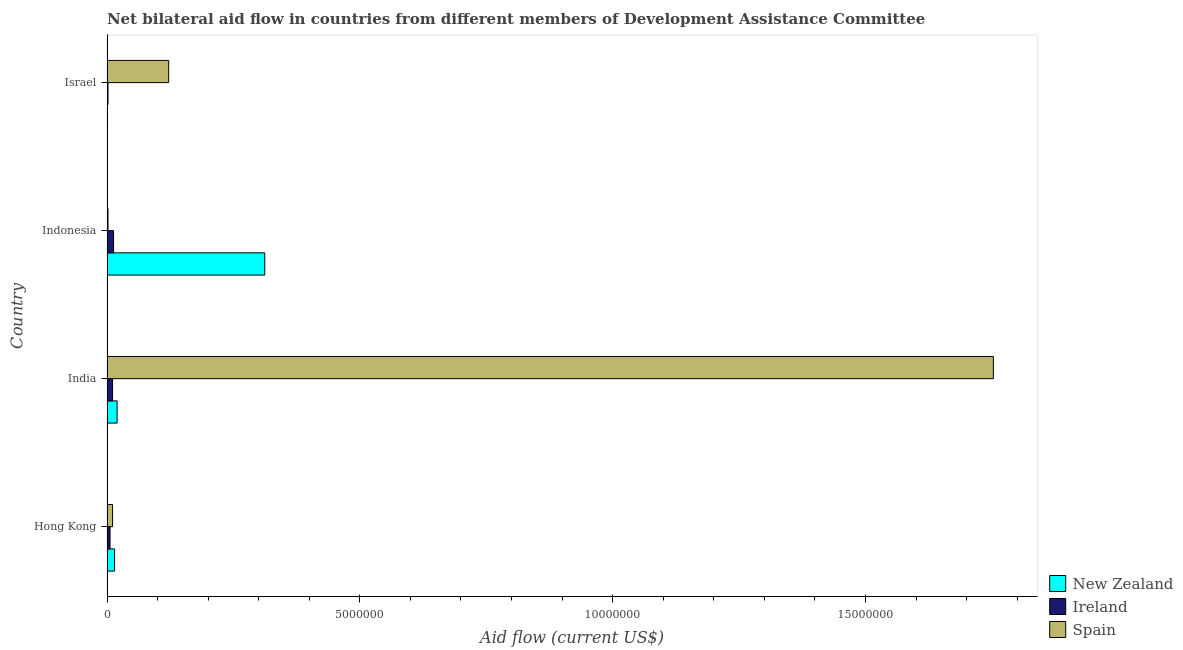How many groups of bars are there?
Your answer should be compact. 4. Are the number of bars on each tick of the Y-axis equal?
Your answer should be compact. Yes. In how many cases, is the number of bars for a given country not equal to the number of legend labels?
Provide a succinct answer. 0. What is the amount of aid provided by ireland in Hong Kong?
Provide a short and direct response. 6.00e+04. Across all countries, what is the maximum amount of aid provided by new zealand?
Ensure brevity in your answer.  3.12e+06. Across all countries, what is the minimum amount of aid provided by new zealand?
Offer a very short reply. 10000. In which country was the amount of aid provided by ireland maximum?
Your answer should be very brief. Indonesia. What is the total amount of aid provided by new zealand in the graph?
Provide a succinct answer. 3.48e+06. What is the difference between the amount of aid provided by spain in Hong Kong and that in India?
Ensure brevity in your answer.  -1.74e+07. What is the difference between the amount of aid provided by spain in Israel and the amount of aid provided by new zealand in Indonesia?
Give a very brief answer. -1.90e+06. What is the average amount of aid provided by ireland per country?
Provide a short and direct response. 8.00e+04. What is the difference between the amount of aid provided by ireland and amount of aid provided by spain in Israel?
Your answer should be compact. -1.20e+06. In how many countries, is the amount of aid provided by spain greater than 9000000 US$?
Keep it short and to the point. 1. What is the ratio of the amount of aid provided by new zealand in Indonesia to that in Israel?
Ensure brevity in your answer.  312. Is the amount of aid provided by new zealand in Hong Kong less than that in Israel?
Make the answer very short. No. What is the difference between the highest and the lowest amount of aid provided by spain?
Make the answer very short. 1.75e+07. In how many countries, is the amount of aid provided by spain greater than the average amount of aid provided by spain taken over all countries?
Your answer should be compact. 1. Is the sum of the amount of aid provided by ireland in Indonesia and Israel greater than the maximum amount of aid provided by spain across all countries?
Offer a very short reply. No. What does the 1st bar from the top in India represents?
Offer a terse response. Spain. What does the 1st bar from the bottom in Israel represents?
Offer a very short reply. New Zealand. Is it the case that in every country, the sum of the amount of aid provided by new zealand and amount of aid provided by ireland is greater than the amount of aid provided by spain?
Offer a terse response. No. Are all the bars in the graph horizontal?
Provide a succinct answer. Yes. How many countries are there in the graph?
Make the answer very short. 4. Are the values on the major ticks of X-axis written in scientific E-notation?
Make the answer very short. No. Does the graph contain any zero values?
Keep it short and to the point. No. Where does the legend appear in the graph?
Offer a very short reply. Bottom right. How many legend labels are there?
Provide a succinct answer. 3. How are the legend labels stacked?
Your answer should be very brief. Vertical. What is the title of the graph?
Provide a short and direct response. Net bilateral aid flow in countries from different members of Development Assistance Committee. What is the label or title of the X-axis?
Your answer should be very brief. Aid flow (current US$). What is the Aid flow (current US$) in Ireland in Hong Kong?
Offer a terse response. 6.00e+04. What is the Aid flow (current US$) in Spain in Hong Kong?
Ensure brevity in your answer.  1.10e+05. What is the Aid flow (current US$) in Ireland in India?
Ensure brevity in your answer.  1.10e+05. What is the Aid flow (current US$) of Spain in India?
Keep it short and to the point. 1.75e+07. What is the Aid flow (current US$) in New Zealand in Indonesia?
Offer a terse response. 3.12e+06. What is the Aid flow (current US$) of Ireland in Indonesia?
Provide a short and direct response. 1.30e+05. What is the Aid flow (current US$) of Spain in Indonesia?
Offer a very short reply. 2.00e+04. What is the Aid flow (current US$) of New Zealand in Israel?
Make the answer very short. 10000. What is the Aid flow (current US$) of Spain in Israel?
Provide a short and direct response. 1.22e+06. Across all countries, what is the maximum Aid flow (current US$) in New Zealand?
Your answer should be very brief. 3.12e+06. Across all countries, what is the maximum Aid flow (current US$) of Ireland?
Your answer should be very brief. 1.30e+05. Across all countries, what is the maximum Aid flow (current US$) in Spain?
Keep it short and to the point. 1.75e+07. Across all countries, what is the minimum Aid flow (current US$) of New Zealand?
Offer a very short reply. 10000. Across all countries, what is the minimum Aid flow (current US$) of Ireland?
Offer a very short reply. 2.00e+04. Across all countries, what is the minimum Aid flow (current US$) in Spain?
Your answer should be compact. 2.00e+04. What is the total Aid flow (current US$) of New Zealand in the graph?
Your answer should be very brief. 3.48e+06. What is the total Aid flow (current US$) of Ireland in the graph?
Give a very brief answer. 3.20e+05. What is the total Aid flow (current US$) of Spain in the graph?
Provide a short and direct response. 1.89e+07. What is the difference between the Aid flow (current US$) in Spain in Hong Kong and that in India?
Provide a succinct answer. -1.74e+07. What is the difference between the Aid flow (current US$) in New Zealand in Hong Kong and that in Indonesia?
Make the answer very short. -2.97e+06. What is the difference between the Aid flow (current US$) in Spain in Hong Kong and that in Indonesia?
Give a very brief answer. 9.00e+04. What is the difference between the Aid flow (current US$) in New Zealand in Hong Kong and that in Israel?
Ensure brevity in your answer.  1.40e+05. What is the difference between the Aid flow (current US$) of Spain in Hong Kong and that in Israel?
Your answer should be very brief. -1.11e+06. What is the difference between the Aid flow (current US$) in New Zealand in India and that in Indonesia?
Give a very brief answer. -2.92e+06. What is the difference between the Aid flow (current US$) in Spain in India and that in Indonesia?
Provide a short and direct response. 1.75e+07. What is the difference between the Aid flow (current US$) in Spain in India and that in Israel?
Ensure brevity in your answer.  1.63e+07. What is the difference between the Aid flow (current US$) of New Zealand in Indonesia and that in Israel?
Offer a terse response. 3.11e+06. What is the difference between the Aid flow (current US$) in Spain in Indonesia and that in Israel?
Ensure brevity in your answer.  -1.20e+06. What is the difference between the Aid flow (current US$) of New Zealand in Hong Kong and the Aid flow (current US$) of Spain in India?
Your answer should be compact. -1.74e+07. What is the difference between the Aid flow (current US$) of Ireland in Hong Kong and the Aid flow (current US$) of Spain in India?
Your answer should be compact. -1.75e+07. What is the difference between the Aid flow (current US$) in New Zealand in Hong Kong and the Aid flow (current US$) in Ireland in Indonesia?
Provide a short and direct response. 2.00e+04. What is the difference between the Aid flow (current US$) of Ireland in Hong Kong and the Aid flow (current US$) of Spain in Indonesia?
Provide a short and direct response. 4.00e+04. What is the difference between the Aid flow (current US$) in New Zealand in Hong Kong and the Aid flow (current US$) in Ireland in Israel?
Offer a very short reply. 1.30e+05. What is the difference between the Aid flow (current US$) of New Zealand in Hong Kong and the Aid flow (current US$) of Spain in Israel?
Your response must be concise. -1.07e+06. What is the difference between the Aid flow (current US$) in Ireland in Hong Kong and the Aid flow (current US$) in Spain in Israel?
Offer a very short reply. -1.16e+06. What is the difference between the Aid flow (current US$) in Ireland in India and the Aid flow (current US$) in Spain in Indonesia?
Make the answer very short. 9.00e+04. What is the difference between the Aid flow (current US$) of New Zealand in India and the Aid flow (current US$) of Ireland in Israel?
Your response must be concise. 1.80e+05. What is the difference between the Aid flow (current US$) in New Zealand in India and the Aid flow (current US$) in Spain in Israel?
Offer a very short reply. -1.02e+06. What is the difference between the Aid flow (current US$) of Ireland in India and the Aid flow (current US$) of Spain in Israel?
Provide a succinct answer. -1.11e+06. What is the difference between the Aid flow (current US$) in New Zealand in Indonesia and the Aid flow (current US$) in Ireland in Israel?
Your answer should be compact. 3.10e+06. What is the difference between the Aid flow (current US$) in New Zealand in Indonesia and the Aid flow (current US$) in Spain in Israel?
Your answer should be compact. 1.90e+06. What is the difference between the Aid flow (current US$) in Ireland in Indonesia and the Aid flow (current US$) in Spain in Israel?
Ensure brevity in your answer.  -1.09e+06. What is the average Aid flow (current US$) of New Zealand per country?
Your response must be concise. 8.70e+05. What is the average Aid flow (current US$) of Spain per country?
Your answer should be compact. 4.72e+06. What is the difference between the Aid flow (current US$) in New Zealand and Aid flow (current US$) in Ireland in Hong Kong?
Your response must be concise. 9.00e+04. What is the difference between the Aid flow (current US$) of Ireland and Aid flow (current US$) of Spain in Hong Kong?
Provide a succinct answer. -5.00e+04. What is the difference between the Aid flow (current US$) in New Zealand and Aid flow (current US$) in Spain in India?
Make the answer very short. -1.73e+07. What is the difference between the Aid flow (current US$) of Ireland and Aid flow (current US$) of Spain in India?
Your response must be concise. -1.74e+07. What is the difference between the Aid flow (current US$) in New Zealand and Aid flow (current US$) in Ireland in Indonesia?
Your answer should be very brief. 2.99e+06. What is the difference between the Aid flow (current US$) in New Zealand and Aid flow (current US$) in Spain in Indonesia?
Provide a short and direct response. 3.10e+06. What is the difference between the Aid flow (current US$) of Ireland and Aid flow (current US$) of Spain in Indonesia?
Your answer should be very brief. 1.10e+05. What is the difference between the Aid flow (current US$) in New Zealand and Aid flow (current US$) in Ireland in Israel?
Make the answer very short. -10000. What is the difference between the Aid flow (current US$) in New Zealand and Aid flow (current US$) in Spain in Israel?
Offer a terse response. -1.21e+06. What is the difference between the Aid flow (current US$) of Ireland and Aid flow (current US$) of Spain in Israel?
Make the answer very short. -1.20e+06. What is the ratio of the Aid flow (current US$) in Ireland in Hong Kong to that in India?
Your answer should be compact. 0.55. What is the ratio of the Aid flow (current US$) in Spain in Hong Kong to that in India?
Keep it short and to the point. 0.01. What is the ratio of the Aid flow (current US$) in New Zealand in Hong Kong to that in Indonesia?
Offer a very short reply. 0.05. What is the ratio of the Aid flow (current US$) of Ireland in Hong Kong to that in Indonesia?
Your answer should be compact. 0.46. What is the ratio of the Aid flow (current US$) in Spain in Hong Kong to that in Indonesia?
Make the answer very short. 5.5. What is the ratio of the Aid flow (current US$) of New Zealand in Hong Kong to that in Israel?
Your answer should be very brief. 15. What is the ratio of the Aid flow (current US$) in Spain in Hong Kong to that in Israel?
Offer a terse response. 0.09. What is the ratio of the Aid flow (current US$) in New Zealand in India to that in Indonesia?
Your response must be concise. 0.06. What is the ratio of the Aid flow (current US$) in Ireland in India to that in Indonesia?
Provide a short and direct response. 0.85. What is the ratio of the Aid flow (current US$) of Spain in India to that in Indonesia?
Provide a short and direct response. 876.5. What is the ratio of the Aid flow (current US$) of New Zealand in India to that in Israel?
Give a very brief answer. 20. What is the ratio of the Aid flow (current US$) in Spain in India to that in Israel?
Make the answer very short. 14.37. What is the ratio of the Aid flow (current US$) in New Zealand in Indonesia to that in Israel?
Provide a short and direct response. 312. What is the ratio of the Aid flow (current US$) of Spain in Indonesia to that in Israel?
Offer a very short reply. 0.02. What is the difference between the highest and the second highest Aid flow (current US$) of New Zealand?
Make the answer very short. 2.92e+06. What is the difference between the highest and the second highest Aid flow (current US$) in Spain?
Provide a succinct answer. 1.63e+07. What is the difference between the highest and the lowest Aid flow (current US$) in New Zealand?
Offer a terse response. 3.11e+06. What is the difference between the highest and the lowest Aid flow (current US$) of Ireland?
Give a very brief answer. 1.10e+05. What is the difference between the highest and the lowest Aid flow (current US$) of Spain?
Offer a terse response. 1.75e+07. 